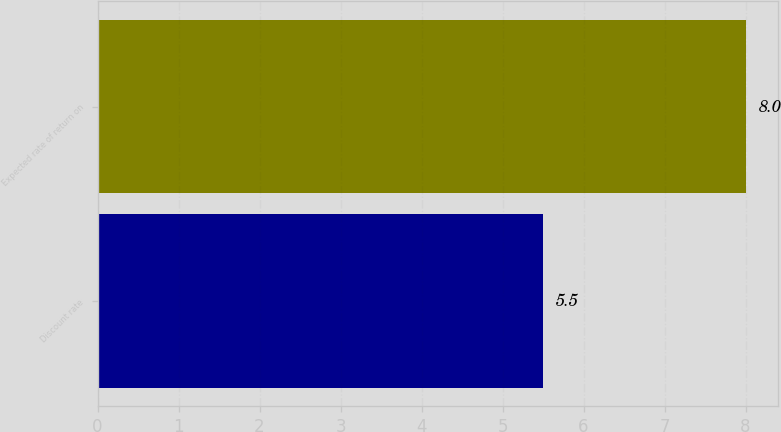<chart> <loc_0><loc_0><loc_500><loc_500><bar_chart><fcel>Discount rate<fcel>Expected rate of return on<nl><fcel>5.5<fcel>8<nl></chart> 